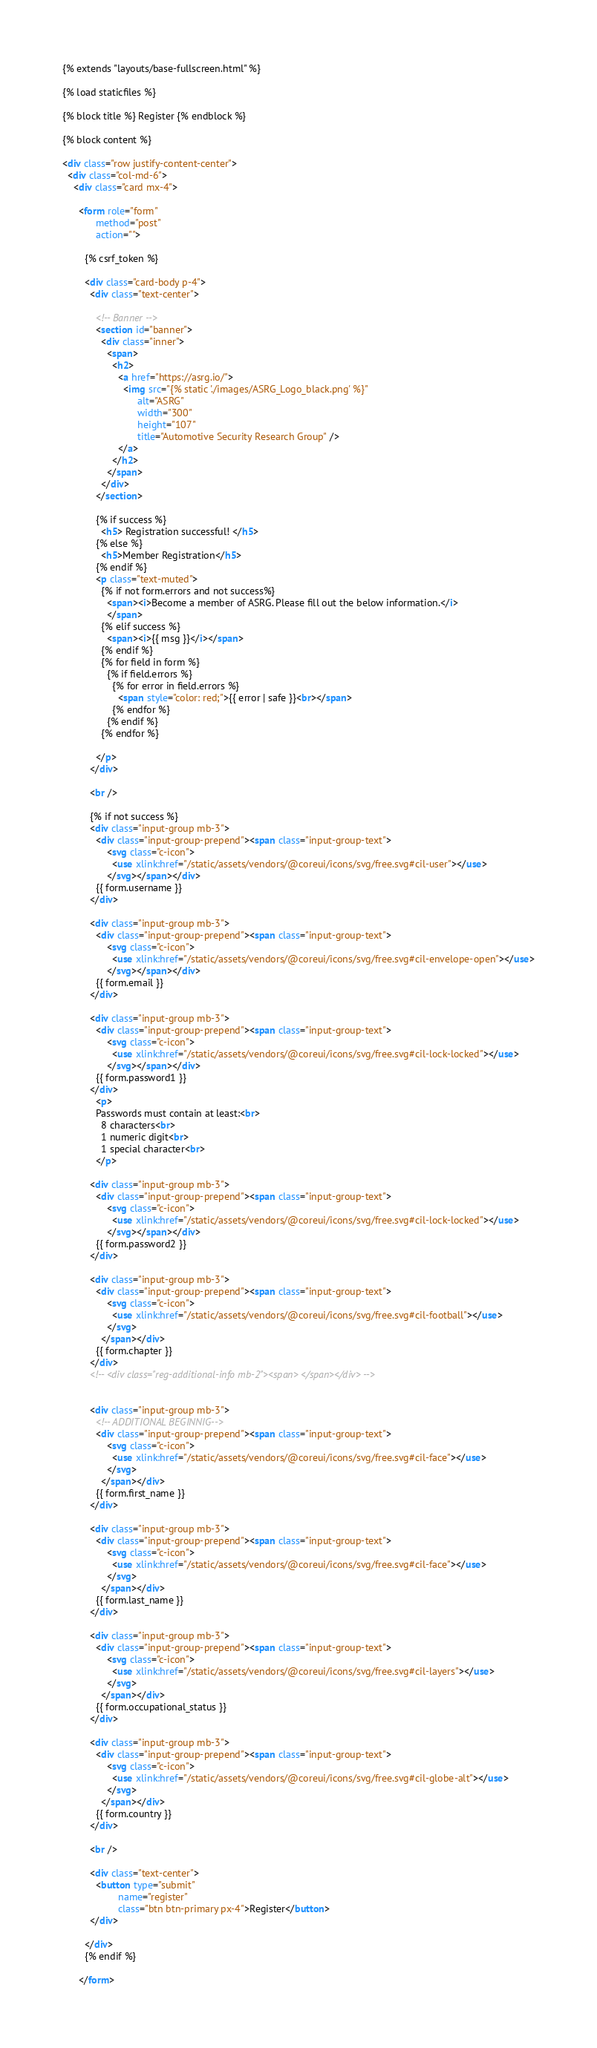Convert code to text. <code><loc_0><loc_0><loc_500><loc_500><_HTML_>{% extends "layouts/base-fullscreen.html" %}

{% load staticfiles %}

{% block title %} Register {% endblock %}

{% block content %}

<div class="row justify-content-center">
  <div class="col-md-6">
    <div class="card mx-4">

      <form role="form"
            method="post"
            action="">

        {% csrf_token %}

        <div class="card-body p-4">
          <div class="text-center">

            <!-- Banner -->
            <section id="banner">
              <div class="inner">
                <span>
                  <h2>
                    <a href="https://asrg.io/">
                      <img src="{% static './images/ASRG_Logo_black.png' %}"
                           alt="ASRG"
                           width="300"
                           height="107"
                           title="Automotive Security Research Group" />
                    </a>
                  </h2>
                </span>
              </div>
            </section>

            {% if success %}
              <h5> Registration successful! </h5>
            {% else %}
              <h5>Member Registration</h5>
            {% endif %}
            <p class="text-muted">
              {% if not form.errors and not success%}
                <span><i>Become a member of ASRG. Please fill out the below information.</i>
                </span>
              {% elif success %}
                <span><i>{{ msg }}</i></span>
              {% endif %}
              {% for field in form %}
                {% if field.errors %}
                  {% for error in field.errors %}
                    <span style="color: red;">{{ error | safe }}<br></span>
                  {% endfor %}
                {% endif %}
              {% endfor %}

            </p>
          </div>

          <br />

          {% if not success %}
          <div class="input-group mb-3">
            <div class="input-group-prepend"><span class="input-group-text">
                <svg class="c-icon">
                  <use xlink:href="/static/assets/vendors/@coreui/icons/svg/free.svg#cil-user"></use>
                </svg></span></div>
            {{ form.username }}
          </div>

          <div class="input-group mb-3">
            <div class="input-group-prepend"><span class="input-group-text">
                <svg class="c-icon">
                  <use xlink:href="/static/assets/vendors/@coreui/icons/svg/free.svg#cil-envelope-open"></use>
                </svg></span></div>
            {{ form.email }}
          </div>

          <div class="input-group mb-3">
            <div class="input-group-prepend"><span class="input-group-text">
                <svg class="c-icon">
                  <use xlink:href="/static/assets/vendors/@coreui/icons/svg/free.svg#cil-lock-locked"></use>
                </svg></span></div>
            {{ form.password1 }}
          </div>
            <p>
            Passwords must contain at least:<br>
              8 characters<br>
              1 numeric digit<br>
              1 special character<br>
            </p>

          <div class="input-group mb-3">
            <div class="input-group-prepend"><span class="input-group-text">
                <svg class="c-icon">
                  <use xlink:href="/static/assets/vendors/@coreui/icons/svg/free.svg#cil-lock-locked"></use>
                </svg></span></div>
            {{ form.password2 }}
          </div>

          <div class="input-group mb-3">
            <div class="input-group-prepend"><span class="input-group-text">
                <svg class="c-icon">
                  <use xlink:href="/static/assets/vendors/@coreui/icons/svg/free.svg#cil-football"></use>
                </svg>
              </span></div>
            {{ form.chapter }}
          </div>
          <!-- <div class="reg-additional-info mb-2"><span> </span></div> -->


          <div class="input-group mb-3">
            <!-- ADDITIONAL BEGINNIG-->
            <div class="input-group-prepend"><span class="input-group-text">
                <svg class="c-icon">
                  <use xlink:href="/static/assets/vendors/@coreui/icons/svg/free.svg#cil-face"></use>
                </svg>
              </span></div>
            {{ form.first_name }}
          </div>

          <div class="input-group mb-3">
            <div class="input-group-prepend"><span class="input-group-text">
                <svg class="c-icon">
                  <use xlink:href="/static/assets/vendors/@coreui/icons/svg/free.svg#cil-face"></use>
                </svg>
              </span></div>
            {{ form.last_name }}
          </div>

          <div class="input-group mb-3">
            <div class="input-group-prepend"><span class="input-group-text">
                <svg class="c-icon">
                  <use xlink:href="/static/assets/vendors/@coreui/icons/svg/free.svg#cil-layers"></use>
                </svg>
              </span></div>
            {{ form.occupational_status }}
          </div>

          <div class="input-group mb-3">
            <div class="input-group-prepend"><span class="input-group-text">
                <svg class="c-icon">
                  <use xlink:href="/static/assets/vendors/@coreui/icons/svg/free.svg#cil-globe-alt"></use>
                </svg>
              </span></div>
            {{ form.country }}
          </div>

          <br />

          <div class="text-center">
            <button type="submit"
                    name="register"
                    class="btn btn-primary px-4">Register</button>
          </div>

        </div>
        {% endif %}

      </form>
</code> 